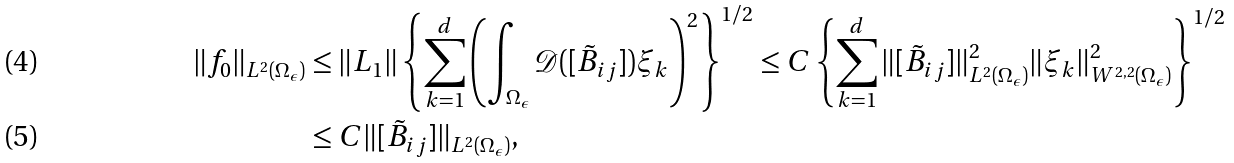<formula> <loc_0><loc_0><loc_500><loc_500>\| f _ { 0 } \| _ { L ^ { 2 } ( \Omega _ { \epsilon } ) } & \leq \| L _ { 1 } \| \left \{ \sum _ { k = 1 } ^ { d } \left ( \int _ { \Omega _ { \epsilon } } \mathcal { D } ( [ \tilde { B } _ { i j } ] ) \xi _ { k } \right ) ^ { 2 } \right \} ^ { 1 / 2 } \leq C \left \{ \sum _ { k = 1 } ^ { d } \| [ \tilde { B } _ { i j } ] \| ^ { 2 } _ { L ^ { 2 } ( \Omega _ { \epsilon } ) } \| \xi _ { k } \| ^ { 2 } _ { W ^ { 2 , 2 } ( \Omega _ { \epsilon } ) } \right \} ^ { 1 / 2 } \\ & \leq C \| [ \tilde { B } _ { i j } ] \| _ { L ^ { 2 } ( \Omega _ { \epsilon } ) } ,</formula> 